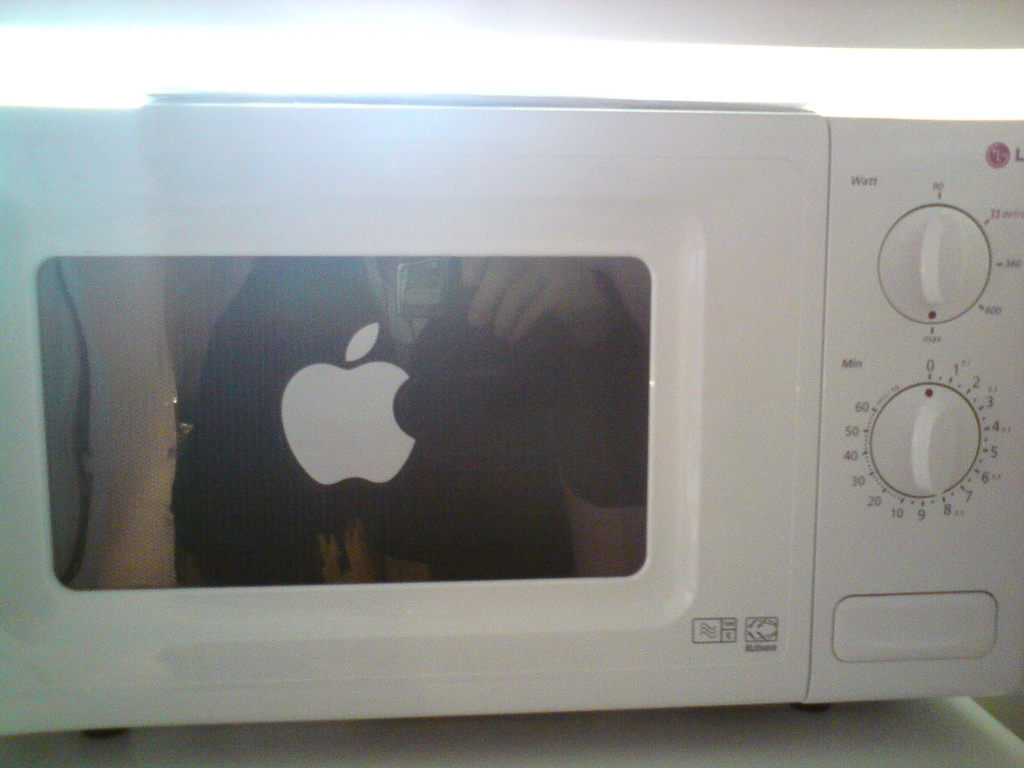Describe the setting where this microwave is located. The microwave is placed in a well-lit, indoor setting, possibly a home or small office kitchen, given the clean and uncluttered countertop seen around it. 